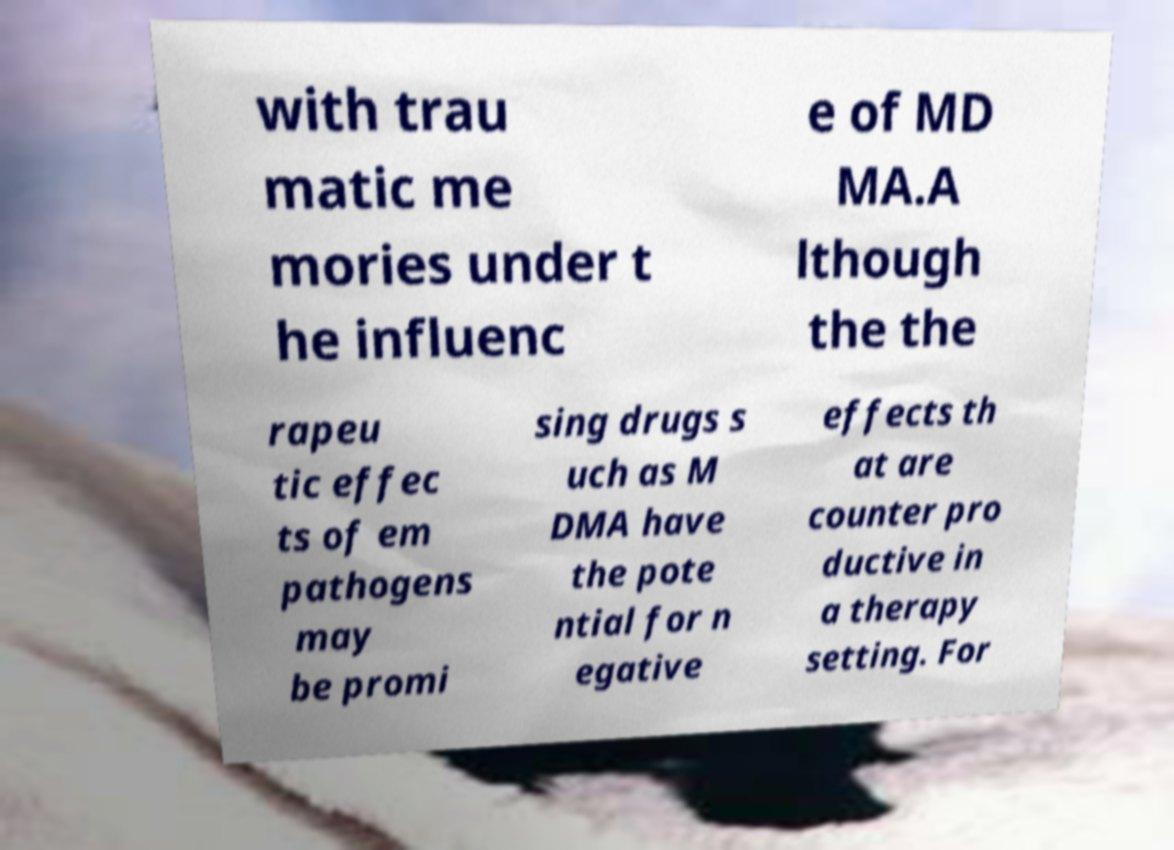Please read and relay the text visible in this image. What does it say? with trau matic me mories under t he influenc e of MD MA.A lthough the the rapeu tic effec ts of em pathogens may be promi sing drugs s uch as M DMA have the pote ntial for n egative effects th at are counter pro ductive in a therapy setting. For 